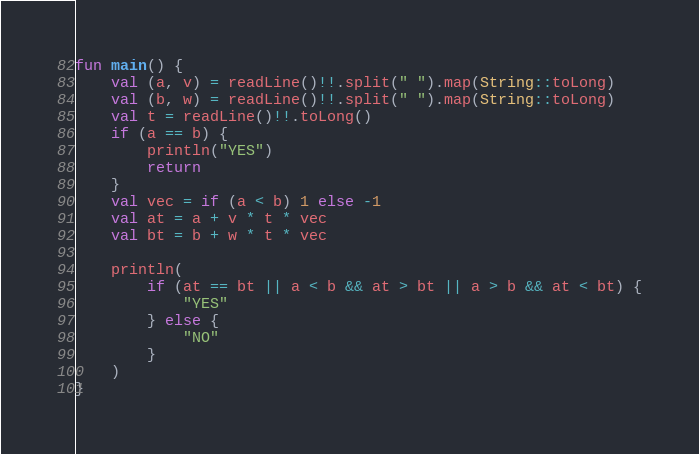<code> <loc_0><loc_0><loc_500><loc_500><_Kotlin_>fun main() {
    val (a, v) = readLine()!!.split(" ").map(String::toLong)
    val (b, w) = readLine()!!.split(" ").map(String::toLong)
    val t = readLine()!!.toLong()
    if (a == b) {
        println("YES")
        return
    }
    val vec = if (a < b) 1 else -1
    val at = a + v * t * vec
    val bt = b + w * t * vec

    println(
        if (at == bt || a < b && at > bt || a > b && at < bt) {
            "YES"
        } else {
            "NO"
        }
    )
}
</code> 